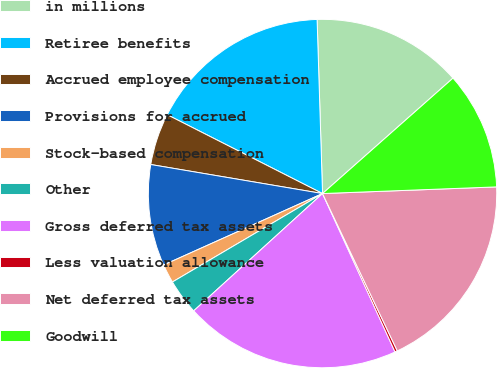Convert chart to OTSL. <chart><loc_0><loc_0><loc_500><loc_500><pie_chart><fcel>in millions<fcel>Retiree benefits<fcel>Accrued employee compensation<fcel>Provisions for accrued<fcel>Stock-based compensation<fcel>Other<fcel>Gross deferred tax assets<fcel>Less valuation allowance<fcel>Net deferred tax assets<fcel>Goodwill<nl><fcel>13.97%<fcel>17.03%<fcel>4.81%<fcel>9.39%<fcel>1.75%<fcel>3.28%<fcel>20.08%<fcel>0.23%<fcel>18.55%<fcel>10.92%<nl></chart> 